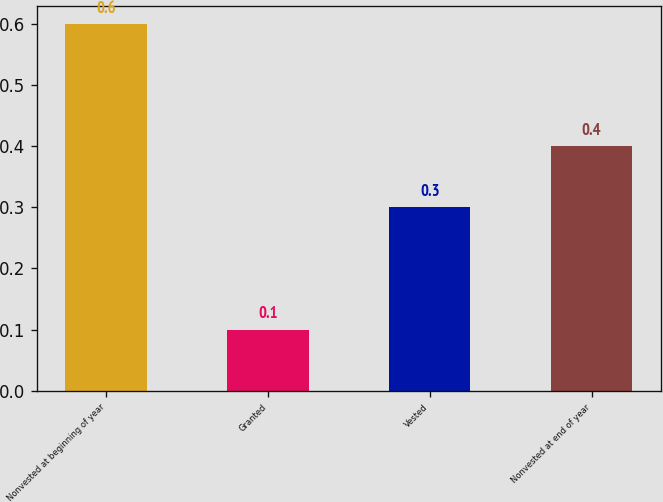Convert chart to OTSL. <chart><loc_0><loc_0><loc_500><loc_500><bar_chart><fcel>Nonvested at beginning of year<fcel>Granted<fcel>Vested<fcel>Nonvested at end of year<nl><fcel>0.6<fcel>0.1<fcel>0.3<fcel>0.4<nl></chart> 